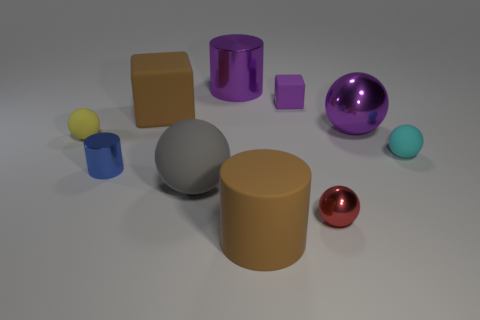Is there a thing that has the same color as the large rubber cylinder?
Give a very brief answer. Yes. What is the size of the matte thing that is the same color as the big block?
Keep it short and to the point. Large. There is a tiny matte block; is it the same color as the large ball on the right side of the matte cylinder?
Your answer should be very brief. Yes. There is a big sphere on the left side of the big shiny object that is in front of the purple rubber block; what is it made of?
Provide a short and direct response. Rubber. How many objects are things that are on the left side of the large purple sphere or small red balls?
Offer a terse response. 8. Are there an equal number of rubber spheres that are behind the yellow object and tiny metallic things that are left of the red shiny ball?
Your answer should be compact. No. What is the material of the small yellow sphere on the left side of the large purple shiny thing behind the large brown block behind the tiny blue cylinder?
Give a very brief answer. Rubber. What is the size of the metallic thing that is left of the red metal thing and in front of the cyan matte ball?
Provide a short and direct response. Small. Is the red metal thing the same shape as the gray matte thing?
Offer a terse response. Yes. What shape is the yellow thing that is the same material as the gray thing?
Offer a very short reply. Sphere. 